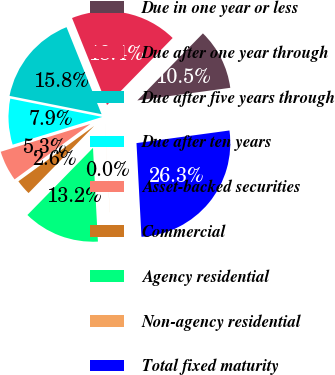Convert chart. <chart><loc_0><loc_0><loc_500><loc_500><pie_chart><fcel>Due in one year or less<fcel>Due after one year through<fcel>Due after five years through<fcel>Due after ten years<fcel>Asset-backed securities<fcel>Commercial<fcel>Agency residential<fcel>Non-agency residential<fcel>Total fixed maturity<nl><fcel>10.53%<fcel>18.42%<fcel>15.79%<fcel>7.9%<fcel>5.27%<fcel>2.64%<fcel>13.16%<fcel>0.01%<fcel>26.31%<nl></chart> 